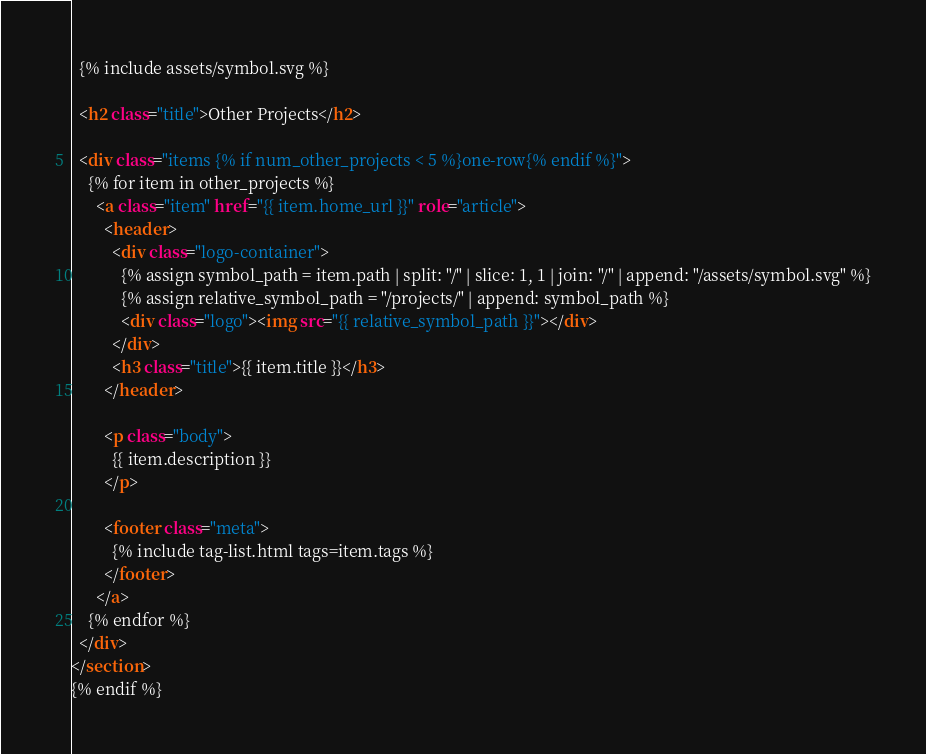<code> <loc_0><loc_0><loc_500><loc_500><_HTML_>  {% include assets/symbol.svg %}

  <h2 class="title">Other Projects</h2>

  <div class="items {% if num_other_projects < 5 %}one-row{% endif %}">
    {% for item in other_projects %}
      <a class="item" href="{{ item.home_url }}" role="article">
        <header>
          <div class="logo-container">
            {% assign symbol_path = item.path | split: "/" | slice: 1, 1 | join: "/" | append: "/assets/symbol.svg" %}
            {% assign relative_symbol_path = "/projects/" | append: symbol_path %}
            <div class="logo"><img src="{{ relative_symbol_path }}"></div>
          </div>
          <h3 class="title">{{ item.title }}</h3>
        </header>

        <p class="body">
          {{ item.description }}
        </p>

        <footer class="meta">
          {% include tag-list.html tags=item.tags %}
        </footer>
      </a>
    {% endfor %}
  </div>
</section>
{% endif %}
</code> 